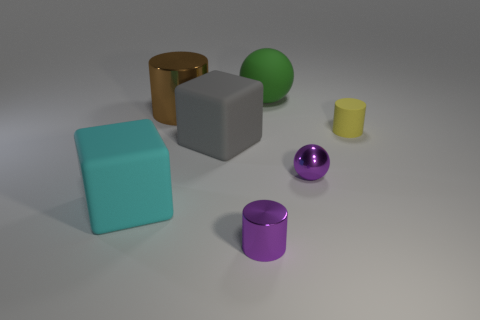Does the small shiny cylinder have the same color as the metallic sphere?
Keep it short and to the point. Yes. What shape is the green object?
Provide a short and direct response. Sphere. There is a big rubber cube on the left side of the big cube that is behind the large cyan cube; what number of big green rubber spheres are to the right of it?
Provide a short and direct response. 1. What color is the big object that is the same shape as the small yellow thing?
Make the answer very short. Brown. The purple shiny object behind the rubber object to the left of the metal cylinder behind the tiny yellow cylinder is what shape?
Offer a terse response. Sphere. There is a thing that is behind the yellow cylinder and in front of the green object; what is its size?
Offer a very short reply. Large. Are there fewer shiny cylinders than small red objects?
Your answer should be very brief. No. What size is the metal cylinder in front of the yellow matte object?
Ensure brevity in your answer.  Small. There is a big thing that is both behind the tiny metal ball and in front of the yellow cylinder; what shape is it?
Keep it short and to the point. Cube. The brown object that is the same shape as the tiny yellow matte thing is what size?
Offer a terse response. Large. 